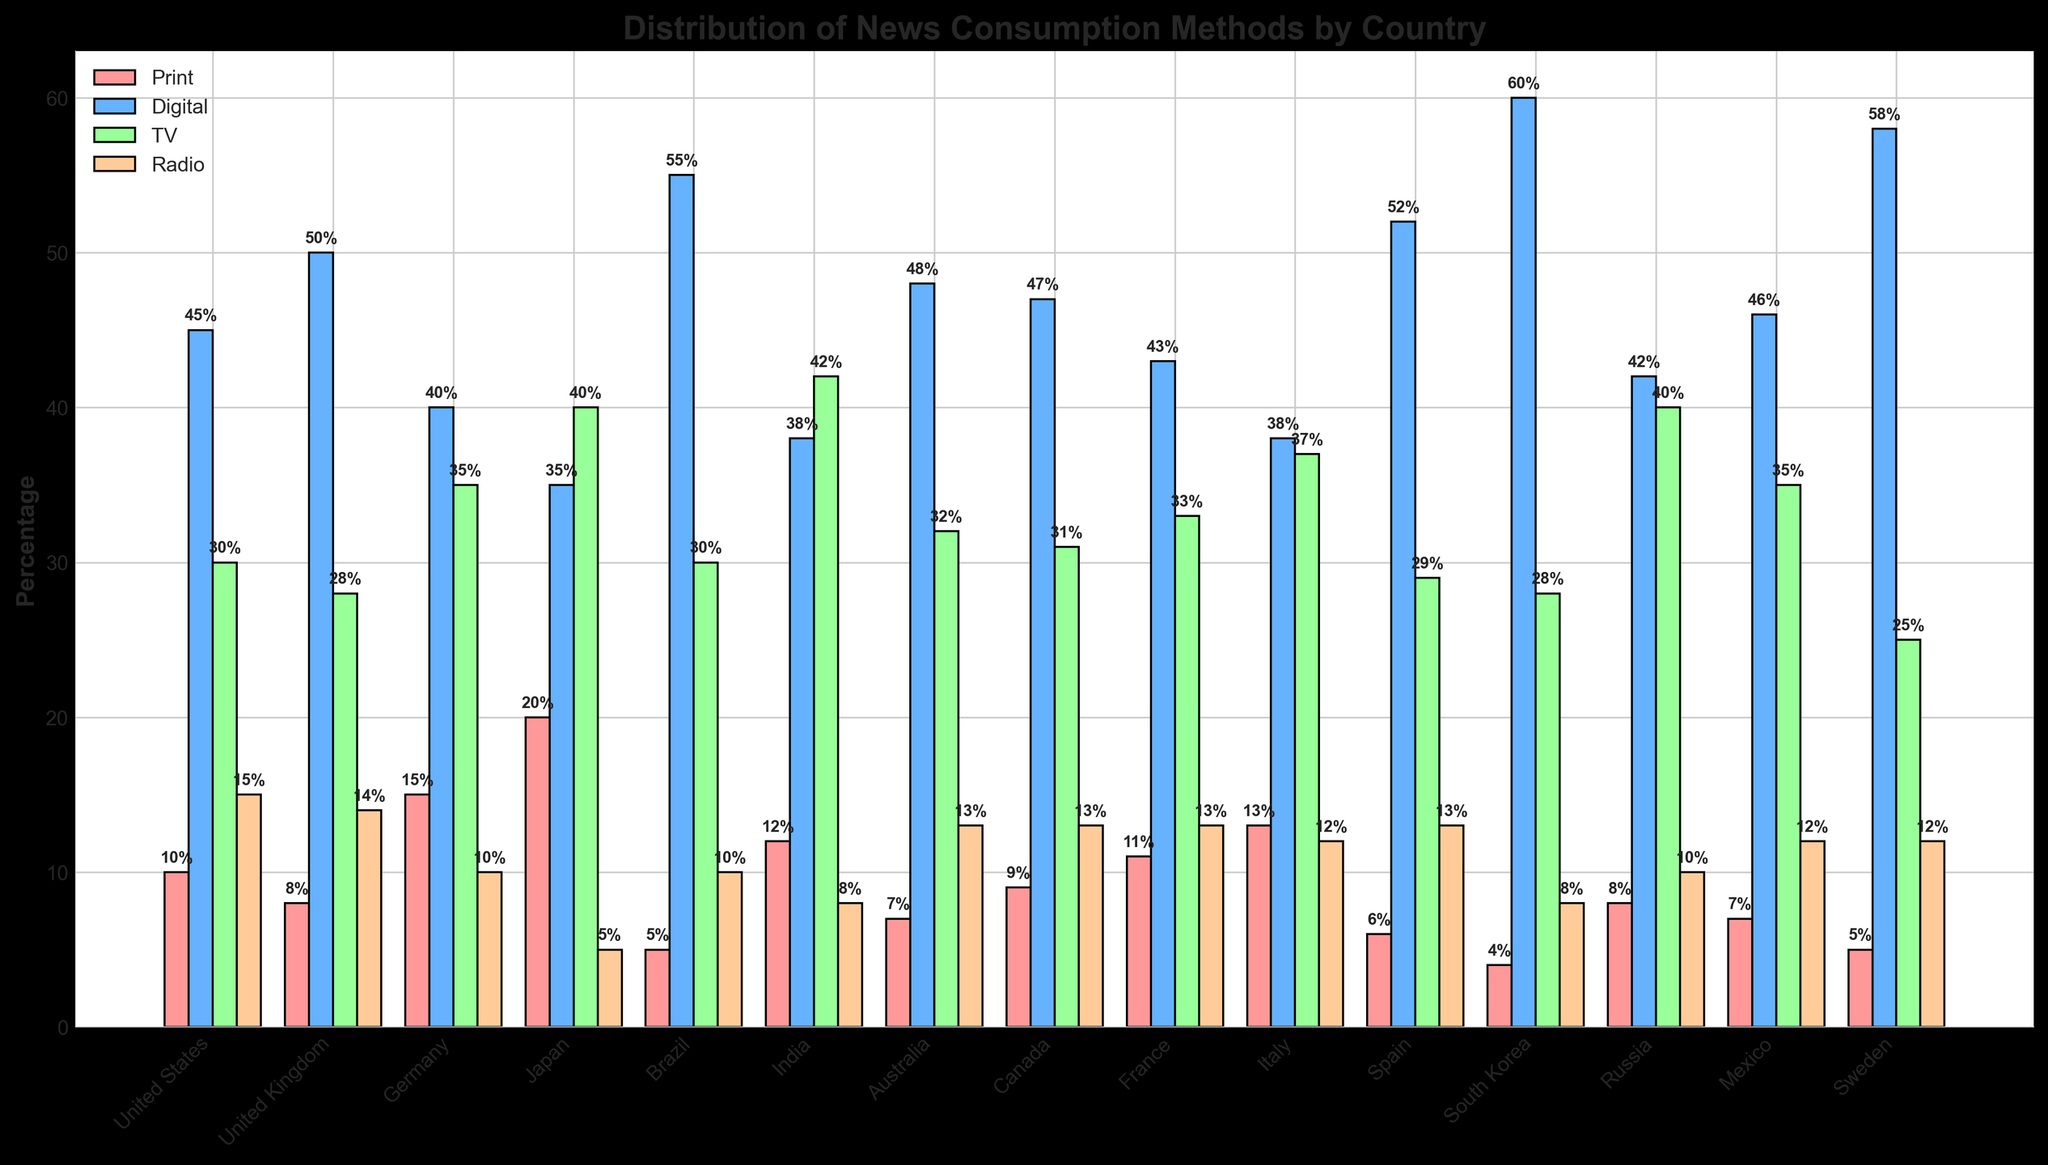Which country has the highest percentage of news consumption through digital methods? Referring to the bar with the highest value under the 'Digital' category, South Korea has the highest percentage.
Answer: South Korea Which country has the lowest percentage of news consumption through print media? The shortest bar under the 'Print' category represents South Korea.
Answer: South Korea What is the combined percentage of TV and radio news consumption in India? The percentage for TV in India is 42% and for radio, it is 8%. Adding them together gives 42 + 8 = 50%.
Answer: 50% Which method of news consumption is more popular in Brazil, print or digital? Comparing the bar heights for print and digital in Brazil, the digital method has a higher percentage at 55% compared to print at 5%.
Answer: Digital What is the difference in the percentage of digital news consumption between Sweden and Brazil? The percentage for digital news consumption is 58% in Sweden and 55% in Brazil. The difference is 58 - 55 = 3%.
Answer: 3% In which country consumption of news through TV is highest? The tallest bar under the 'TV' category represents Japan, with a percentage value of 40%.
Answer: Japan What is the average percentage of radio news consumption across all the countries? The percentages for radio consumption across the 15 countries are: 15, 14, 10, 5, 10, 8, 13, 13, 13, 12, 13, 8, 10, 12, and 12. Adding these gives a total of 170. The average is 170 / 15 = 11.33%.
Answer: 11.33% Which country has the closest percentage of print and TV news consumption? Sorting the differences between print and TV percentages for each country, the smallest difference is in Italy with 13% for print and 37% for TV, having a difference of 37 - 13 = 24%.
Answer: Italy For which country is the percentage of digital news consumption exactly twice as much as the combined percentage of print and radio? We first calculate the combined percentages of print and radio for each country, then see if any match half of their digital percentage. In the United Kingdom, print + radio = 8 + 14 = 22, and digital = 50. Since 22 * 2 = 44, this matches the criterion.
Answer: No such country Compare the popularity of TV and digital news consumption in Australia. Which one is higher and by how much? The TV percentage in Australia is 32%, while for digital it is 48%. The difference is 48 - 32 = 16%. Hence, digital is more popular.
Answer: Digital, by 16% 